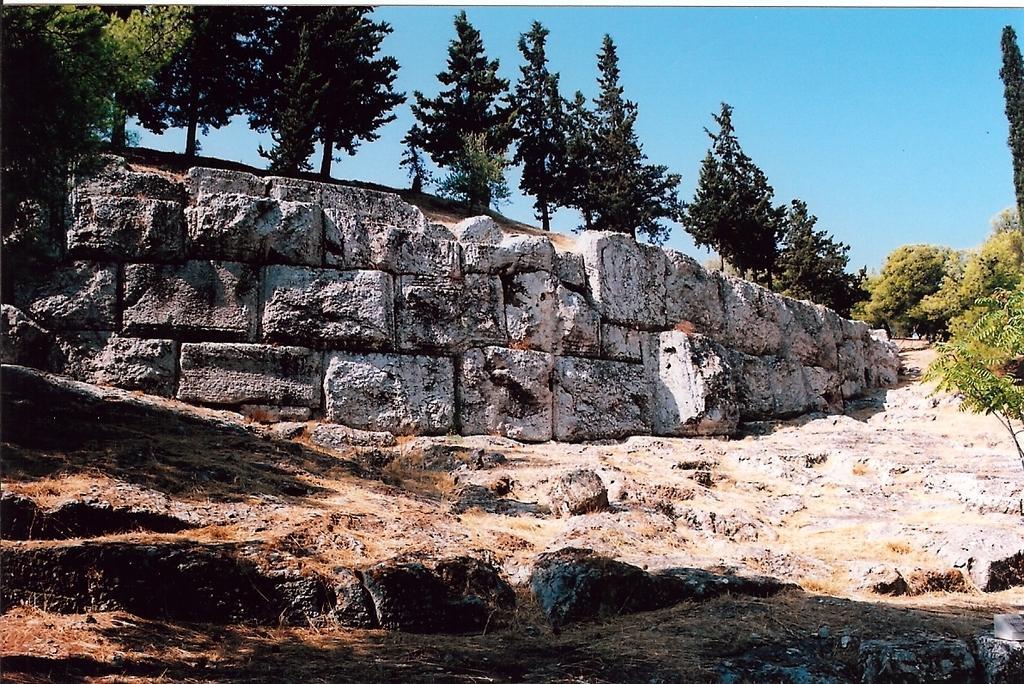Please provide a concise description of this image. In this picture we can see few rocks and trees. 